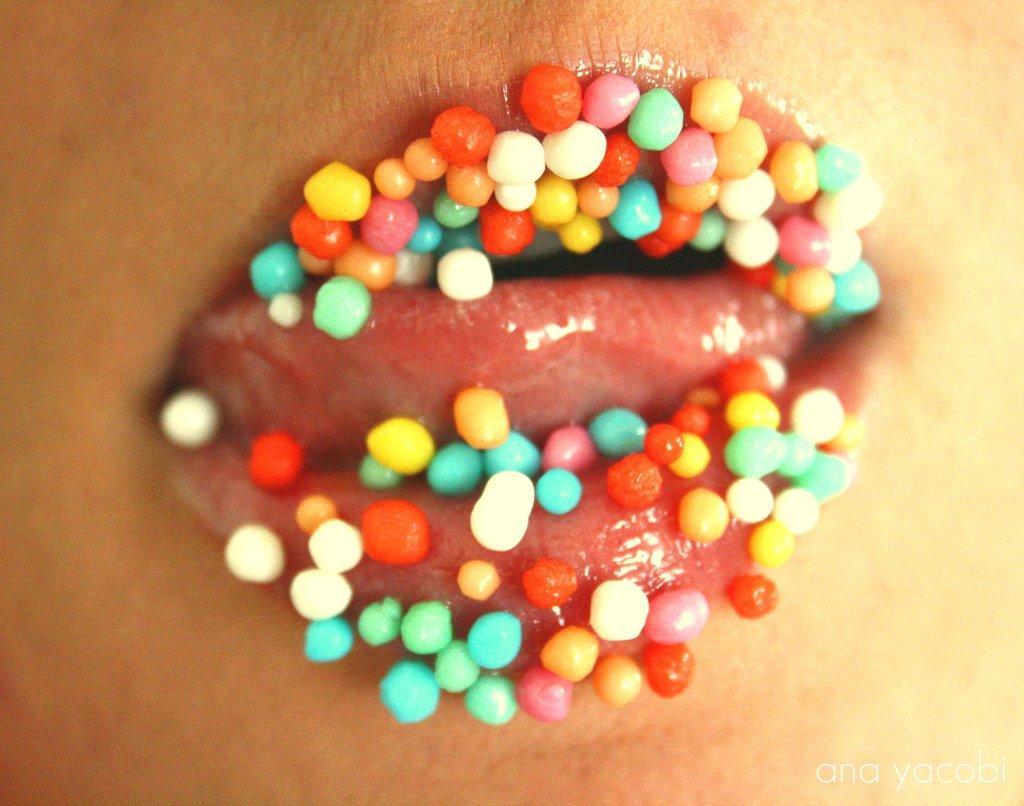How would you summarize this image in a sentence or two? In this picture we can see a close view of the person lips, with colorful thermocol balls. 